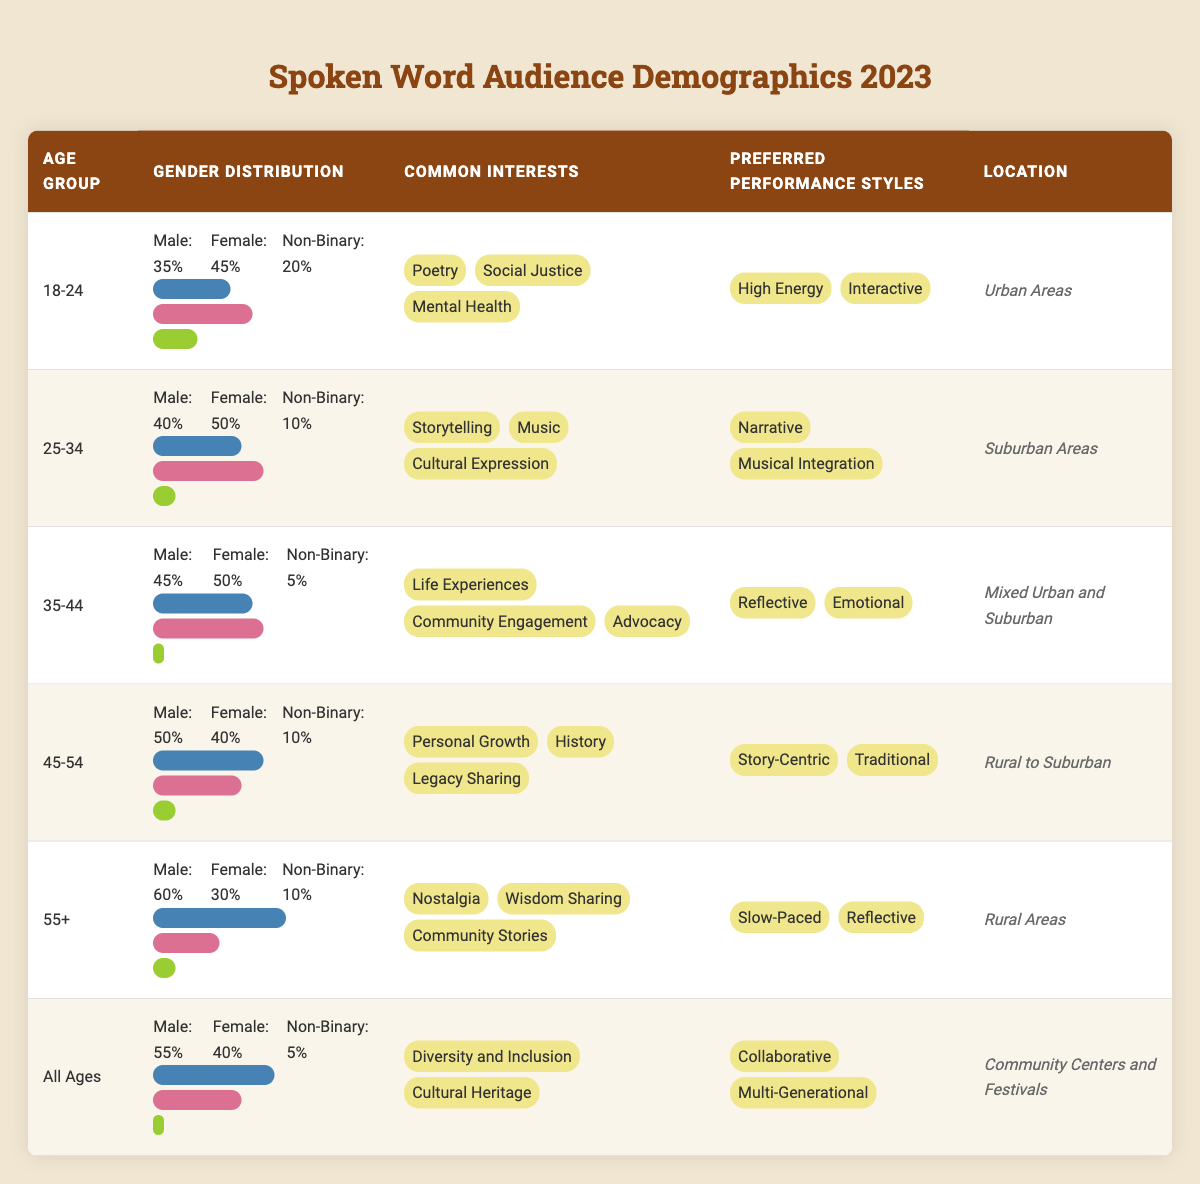What is the gender distribution of the audience aged 45-54? For the age group 45-54, the gender distribution is listed in the table as Male: 50%, Female: 40%, and Non-Binary: 10%. This can be found in the specific row for that age group in the Gender Distribution column.
Answer: Male: 50%, Female: 40%, Non-Binary: 10% Which age group has the highest percentage of male audience members? By checking the Gender Distribution for each age group, the highest percentage of male audience members is found in the 55+ age group at 60%. This involves simply comparing the percentages of males across all age groups.
Answer: 55+ Is the common interest "Cultural Expression" mentioned for any age group? In the table, "Cultural Expression" is listed under the Common Interests for the age group 25-34. Thus, the answer is found in the corresponding row for that age group.
Answer: Yes What is the average percentage of Non-Binary individuals across all age groups? To find the average, add the percentages of Non-Binary individuals from each age group: (20 + 10 + 5 + 10 + 10 + 5) = 70. Since there are 6 age groups, the average is 70/6 = 11.67%.
Answer: 11.67% Do the audiences aged 35-44 and 45-54 have the same preferred performance style? The age group 35-44 prefers "Reflective" and "Emotional", while the age group 45-54 prefers "Story-Centric" and "Traditional". Since these styles differ for the two groups, the answer is no. This comparison can be seen by checking the Preferred Performance Styles for both age groups.
Answer: No How many Common Interests are shared between the age groups 18-24 and 25-34? The Common Interests for 18-24 include "Poetry", "Social Justice", and "Mental Health". For 25-34, the Common Interests are "Storytelling", "Music", and "Cultural Expression". There are no shared interests, as both lists are different.
Answer: 0 Which location category is most frequently mentioned in the table? By reviewing the Location column, Urban Areas appears once (for the 18-24 age group), Suburban Areas appears once (for the 25-34 age group), Mixed Urban and Suburban appears once (for the 35-44 age group), Rural to Suburban appears once (for the 45-54 age group), Rural Areas appears once (for the 55+ age group), and Community Centers and Festivals appears once (for All Ages). Thus, all categories are mentioned equally once.
Answer: None (equal mention) What percentage of the audience aged 55+ is female? In the age group 55+, the table indicates that the Female percentage of the audience is 30%. This information can be found directly in the Gender Distribution section of that age group.
Answer: 30% 